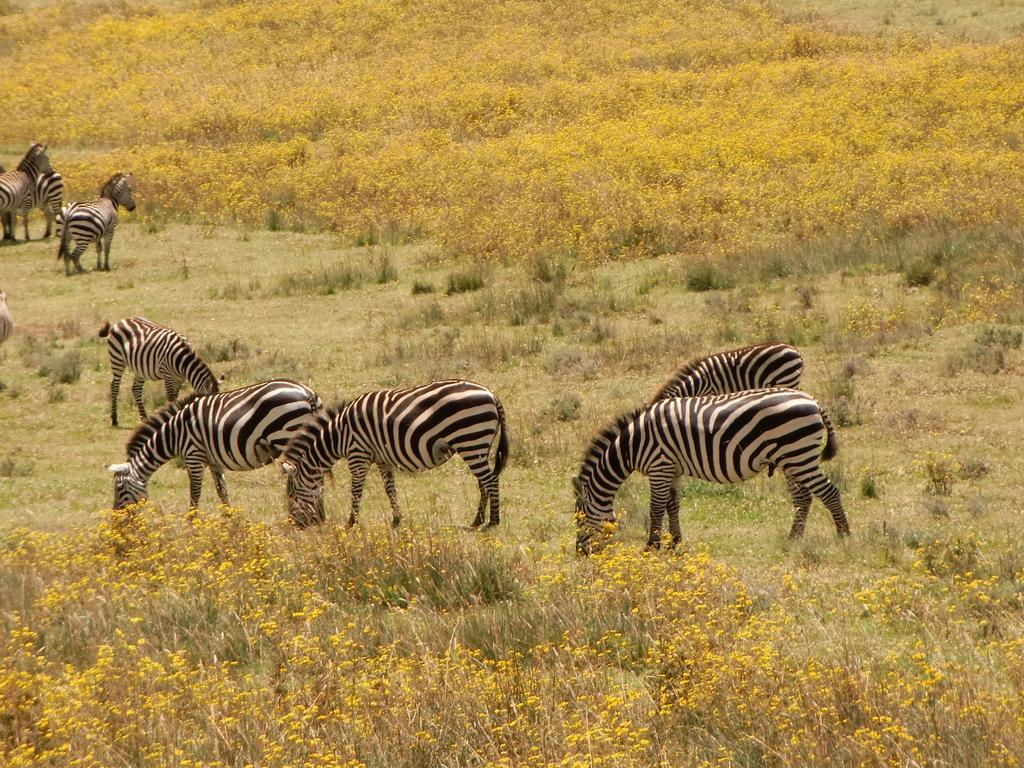What animals are present in the image? There are many zebras in the image. Where are the zebras located? The zebras are standing in a grass field. What is the condition of the grass field? The grass field is covered with flowers. Are there any other plants visible in the grass field? Yes, there are bushes in the grass field. Can you see any sleet falling in the image? No, there is no sleet present in the image; it features a grass field with zebras and flowers. Is there a basketball court visible in the image? No, there is no basketball court present in the image; it features a grass field with zebras and flowers. 